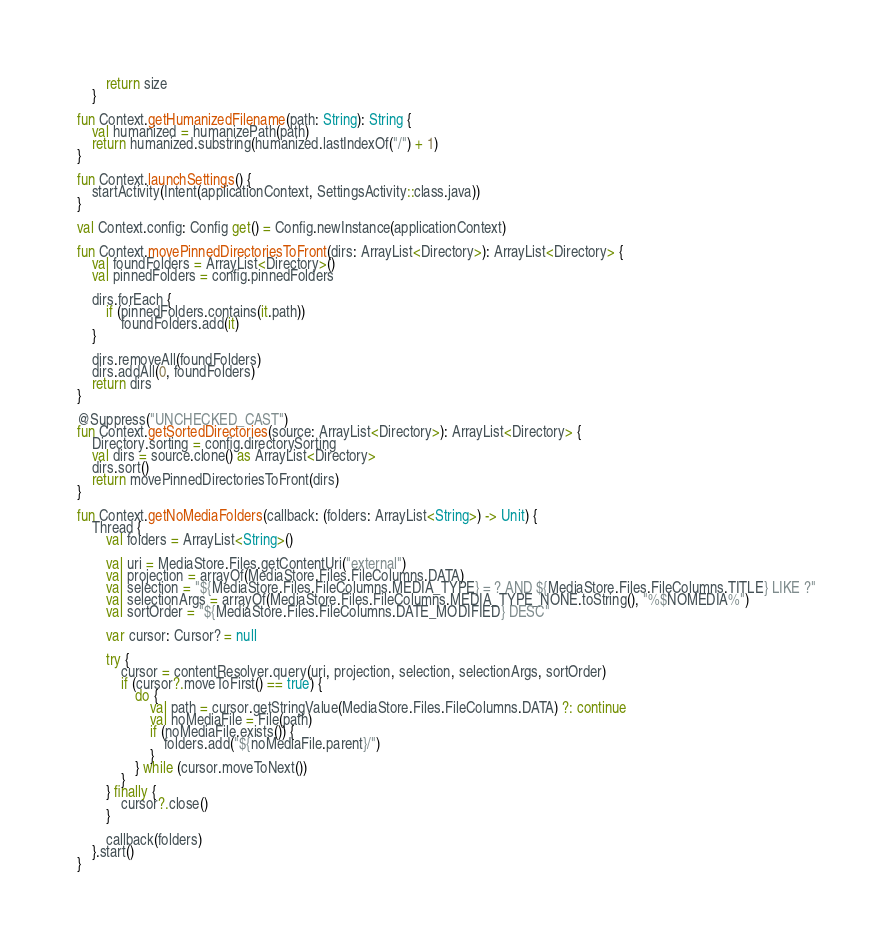<code> <loc_0><loc_0><loc_500><loc_500><_Kotlin_>        return size
    }

fun Context.getHumanizedFilename(path: String): String {
    val humanized = humanizePath(path)
    return humanized.substring(humanized.lastIndexOf("/") + 1)
}

fun Context.launchSettings() {
    startActivity(Intent(applicationContext, SettingsActivity::class.java))
}

val Context.config: Config get() = Config.newInstance(applicationContext)

fun Context.movePinnedDirectoriesToFront(dirs: ArrayList<Directory>): ArrayList<Directory> {
    val foundFolders = ArrayList<Directory>()
    val pinnedFolders = config.pinnedFolders

    dirs.forEach {
        if (pinnedFolders.contains(it.path))
            foundFolders.add(it)
    }

    dirs.removeAll(foundFolders)
    dirs.addAll(0, foundFolders)
    return dirs
}

@Suppress("UNCHECKED_CAST")
fun Context.getSortedDirectories(source: ArrayList<Directory>): ArrayList<Directory> {
    Directory.sorting = config.directorySorting
    val dirs = source.clone() as ArrayList<Directory>
    dirs.sort()
    return movePinnedDirectoriesToFront(dirs)
}

fun Context.getNoMediaFolders(callback: (folders: ArrayList<String>) -> Unit) {
    Thread {
        val folders = ArrayList<String>()

        val uri = MediaStore.Files.getContentUri("external")
        val projection = arrayOf(MediaStore.Files.FileColumns.DATA)
        val selection = "${MediaStore.Files.FileColumns.MEDIA_TYPE} = ? AND ${MediaStore.Files.FileColumns.TITLE} LIKE ?"
        val selectionArgs = arrayOf(MediaStore.Files.FileColumns.MEDIA_TYPE_NONE.toString(), "%$NOMEDIA%")
        val sortOrder = "${MediaStore.Files.FileColumns.DATE_MODIFIED} DESC"

        var cursor: Cursor? = null

        try {
            cursor = contentResolver.query(uri, projection, selection, selectionArgs, sortOrder)
            if (cursor?.moveToFirst() == true) {
                do {
                    val path = cursor.getStringValue(MediaStore.Files.FileColumns.DATA) ?: continue
                    val noMediaFile = File(path)
                    if (noMediaFile.exists()) {
                        folders.add("${noMediaFile.parent}/")
                    }
                } while (cursor.moveToNext())
            }
        } finally {
            cursor?.close()
        }

        callback(folders)
    }.start()
}
</code> 